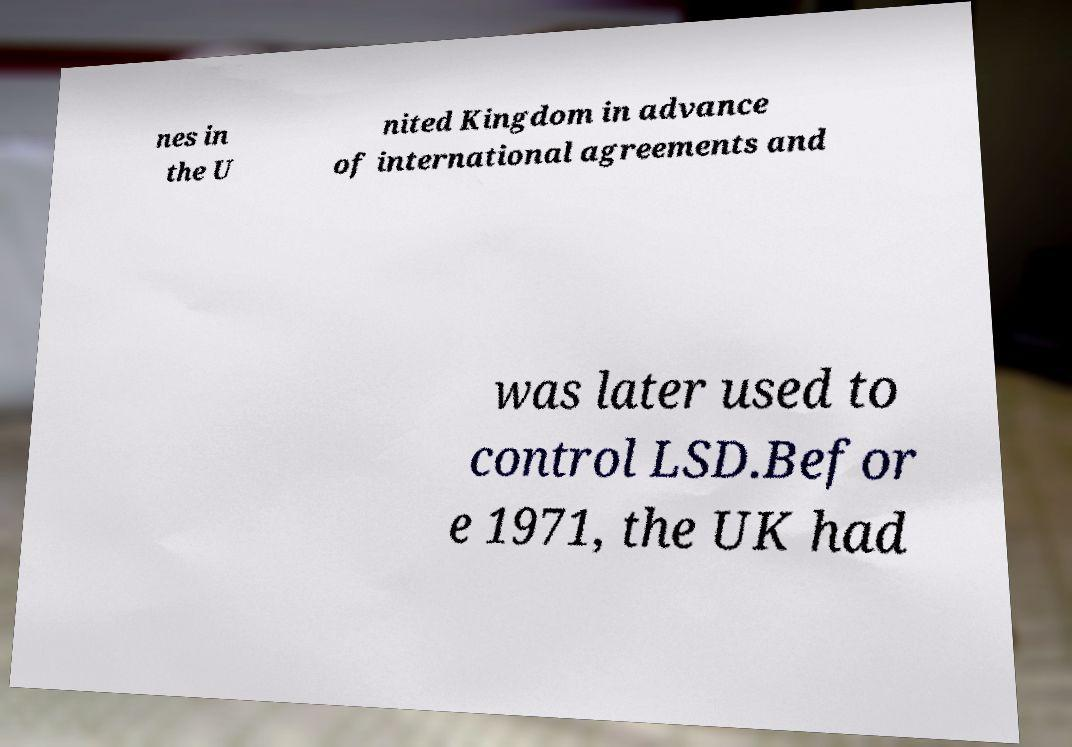Can you read and provide the text displayed in the image?This photo seems to have some interesting text. Can you extract and type it out for me? nes in the U nited Kingdom in advance of international agreements and was later used to control LSD.Befor e 1971, the UK had 